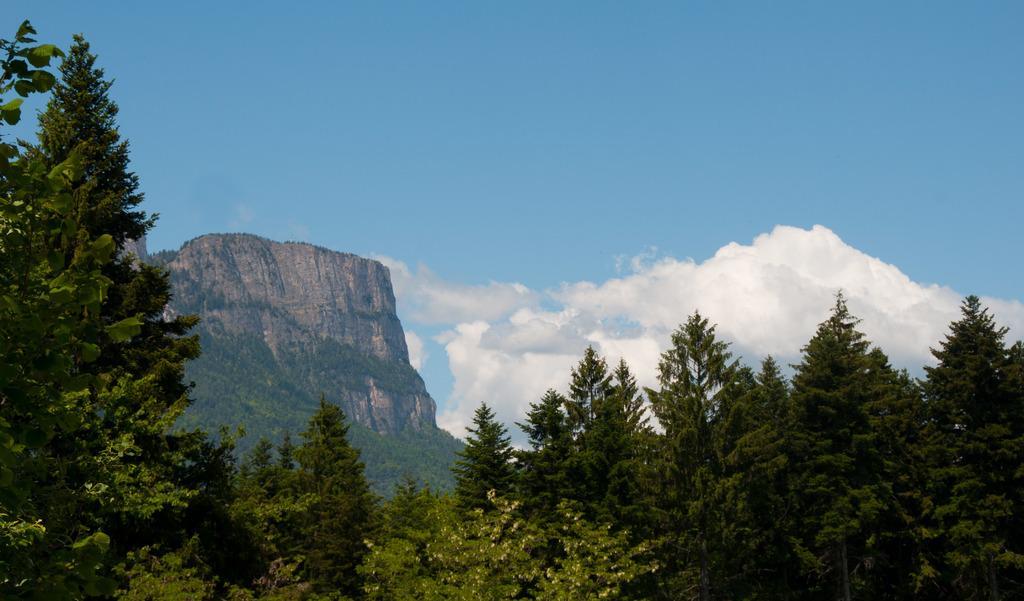Can you describe this image briefly? In this image we can see the hill and also many trees. In the background there is sky with some clouds. 